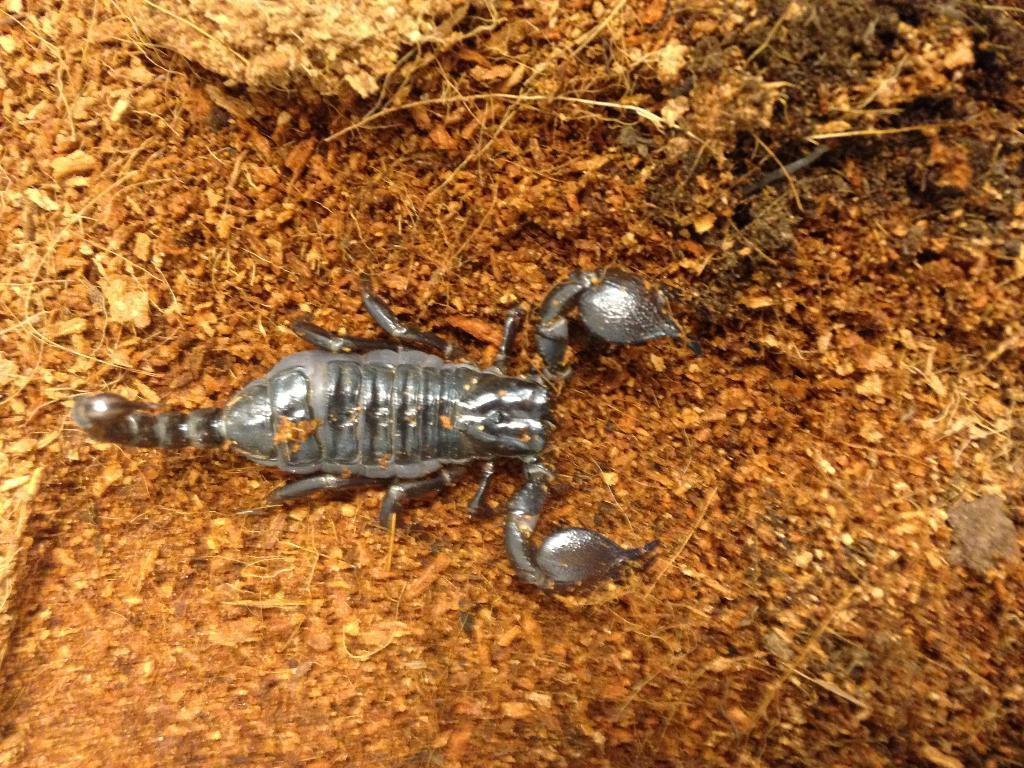What is the main subject of the picture? The main subject of the picture is a scorpion. Can you describe the color of the scorpion? The scorpion is grey in color. What can be seen in the background of the picture? There are dry leaves and twigs in the background of the picture. Which actor is playing the role of the scorpion in the image? There is no actor present in the image; it is a photograph of a real scorpion. Can you see a rabbit hiding among the dry leaves in the image? There is no rabbit present in the image; it only features a scorpion and the background elements. 